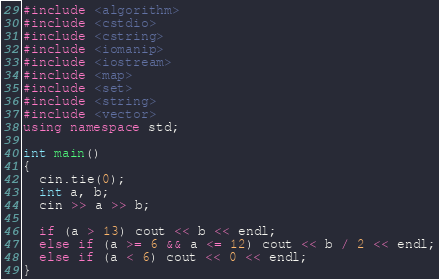<code> <loc_0><loc_0><loc_500><loc_500><_C++_>#include <algorithm>
#include <cstdio>
#include <cstring>
#include <iomanip>
#include <iostream>
#include <map>
#include <set>
#include <string>
#include <vector>
using namespace std;

int main()
{
  cin.tie(0);
  int a, b;
  cin >> a >> b;

  if (a > 13) cout << b << endl;
  else if (a >= 6 && a <= 12) cout << b / 2 << endl;
  else if (a < 6) cout << 0 << endl;
}</code> 